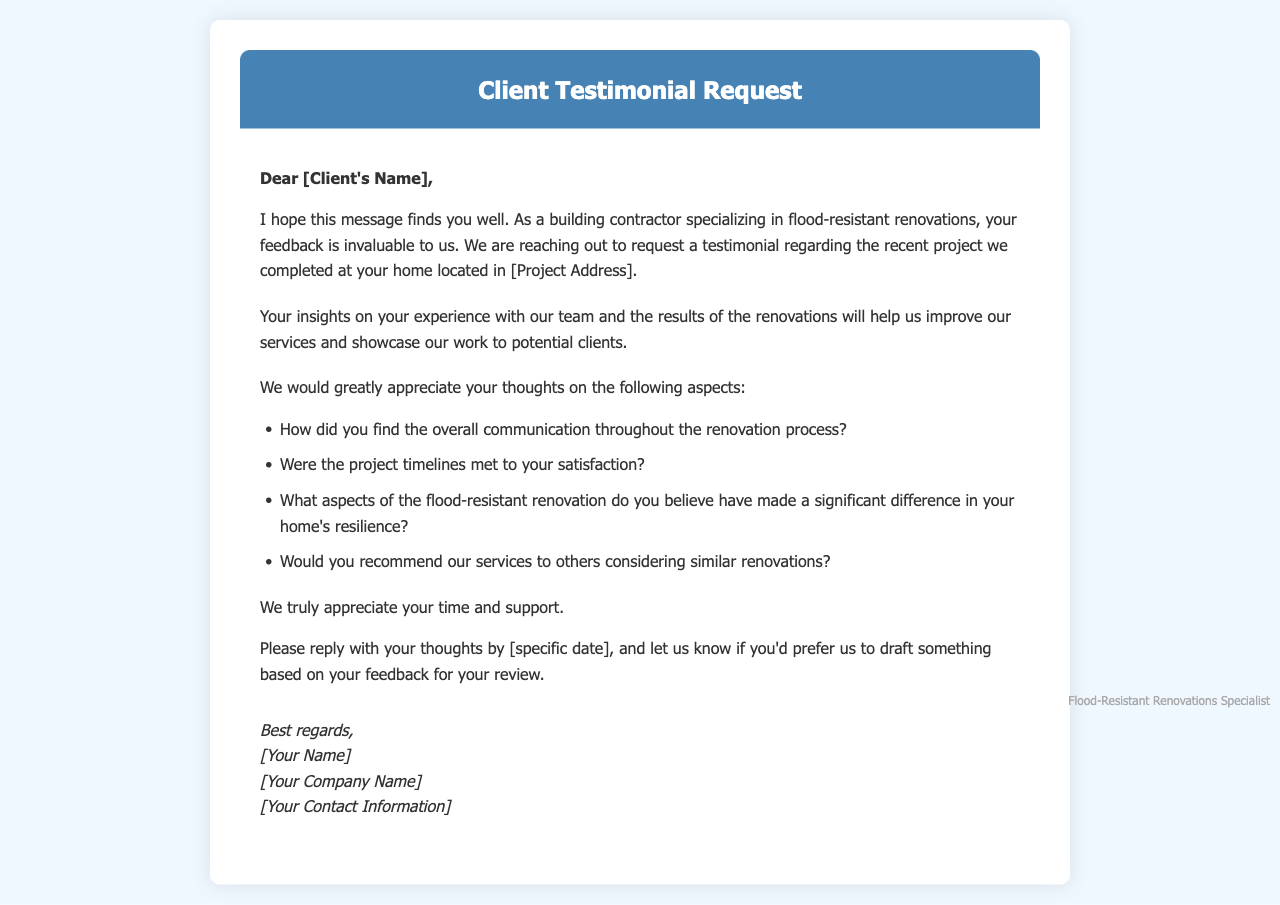What is the title of the document? The title is indicated in the header of the document as "Client Testimonial Request."
Answer: Client Testimonial Request What is the purpose of the request? The purpose is to ask for feedback about the recent project completed at the client's home for service improvement and showcasing work.
Answer: Feedback Who is the sender of the document? The sender's name is indicated at the bottom of the document in the signature section.
Answer: [Your Name] What specific aspects does the document request opinions on? The document lists four specific aspects regarding the project and communication for which feedback is requested.
Answer: Communication, timelines, renovation impacts, recommendations By what date does the document request a response? The document specifies a deadline for the client's response, which is noted as a placeholder in the text.
Answer: [specific date] What type of projects does the author specialize in? The author specializes in renovations designed to withstand flooding as mentioned at the beginning.
Answer: Flood-resistant renovations What color is used for the header? The header color is mentioned explicitly in the style section of the document.
Answer: #4682b4 What is the maximum width of the container in the document? The maximum width of the container for the content is stated clearly in the style settings.
Answer: 800px 